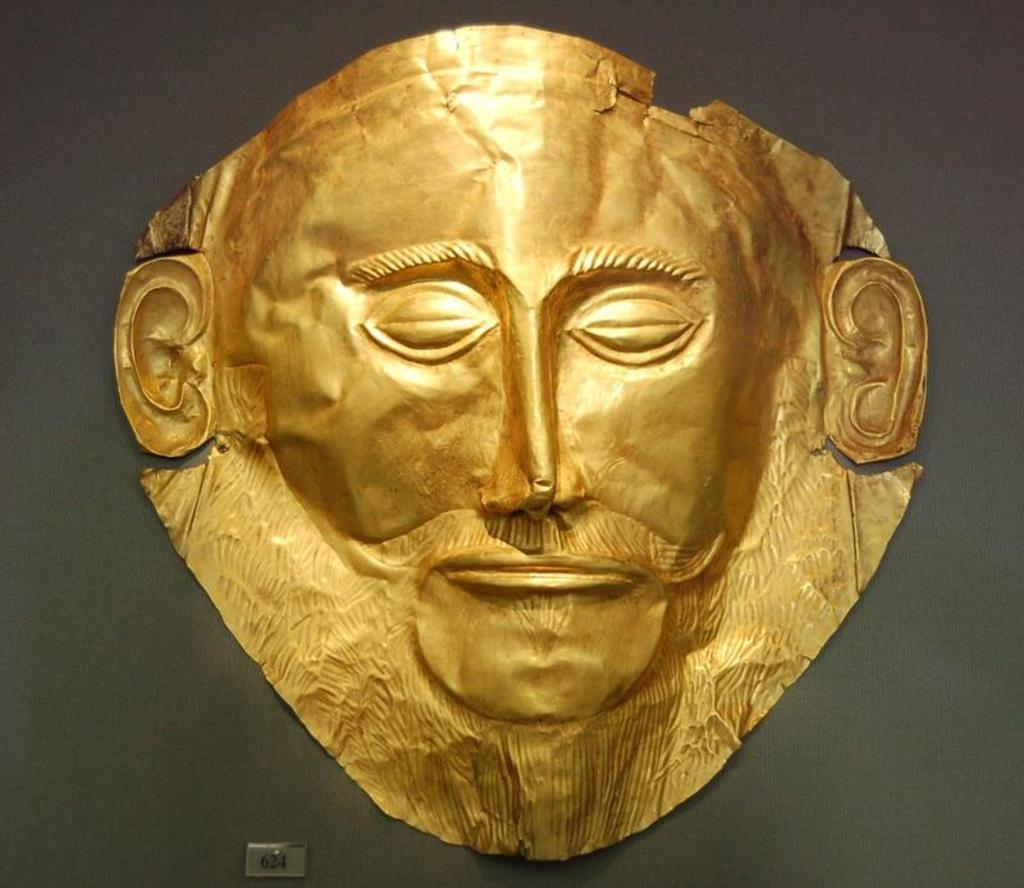What type of mask is depicted in the image? There is a mask of Agamemnon in the image. What can be seen on the door in the image? There is visible light on the door in the image. Are there any numbers visible in the image? Yes, there are numbers visible at the bottom of the image. What invention is being demonstrated by the waves in the image? There are no waves present in the image, so it is not possible to discuss any inventions related to them. 